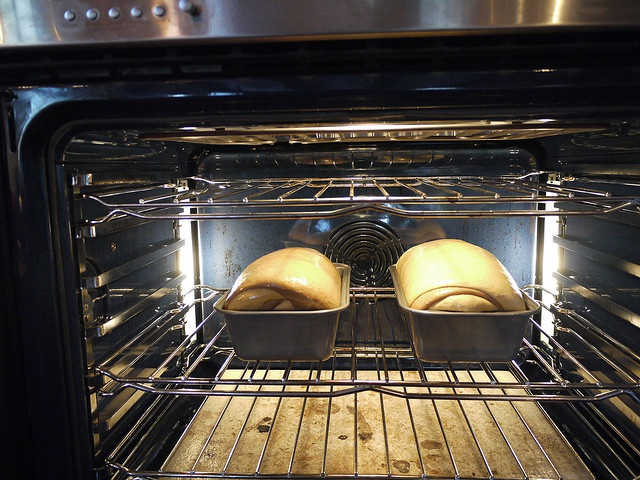Describe the objects in this image and their specific colors. I can see a oven in black, gray, khaki, and tan tones in this image. 